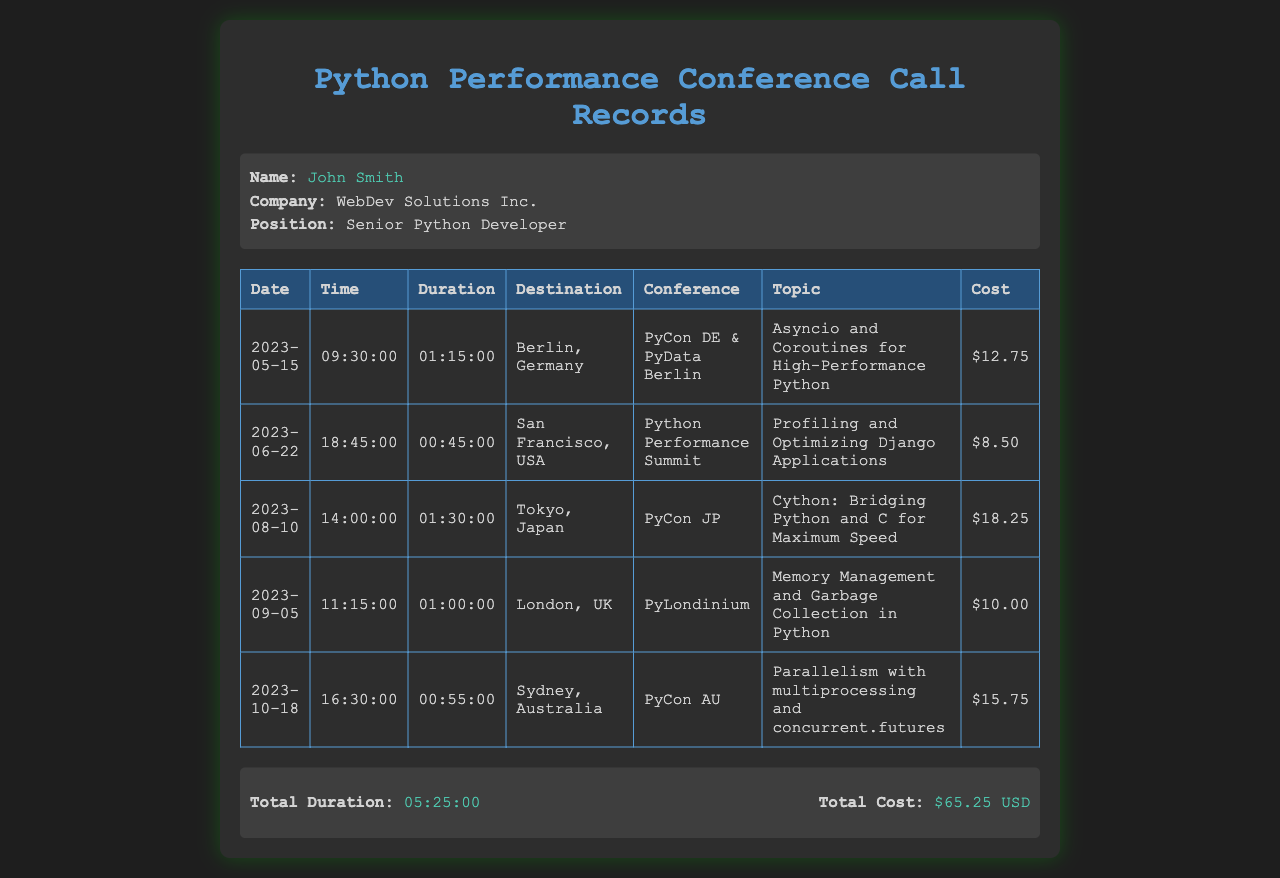What is the total duration of the calls? The total duration is listed in the document as the sum of all call durations.
Answer: 05:25:00 Who attended the conference? The name of the attendee is mentioned in the document.
Answer: John Smith What was the cost of the call to Tokyo, Japan? The document specifies the cost associated with the Tokyo call.
Answer: $18.25 What topic was discussed at the San Francisco conference? Each entry lists the conference topic alongside the destination.
Answer: Profiling and Optimizing Django Applications Which conference took place on October 18, 2023? This date appears in the records, and the associated conference name is noted.
Answer: PyCon AU What is the total cost of all calls? The document sums up the cost incurred for all the calls.
Answer: $65.25 USD Where was the conference that discussed Asyncio and Coroutines? The document links the topic to a specific destination.
Answer: Berlin, Germany How long was the call to London, UK? The call duration for that entry can be found in the document.
Answer: 01:00:00 